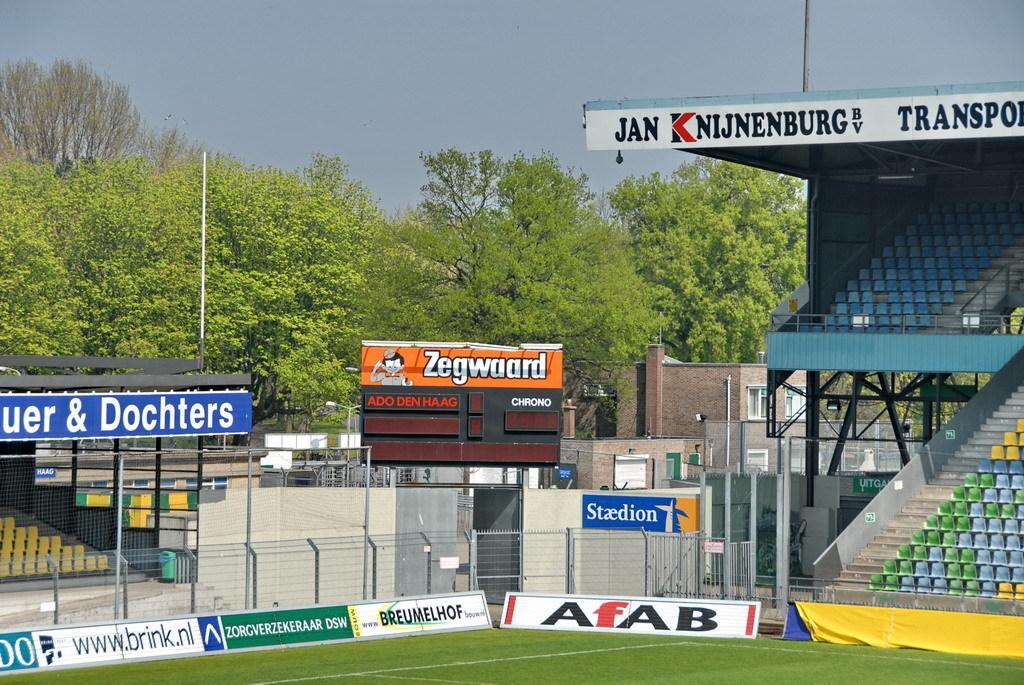Can you describe this image briefly? This is grass. Here we can see boards, fence, chairs, poles, building, and trees. In the background there is sky. 